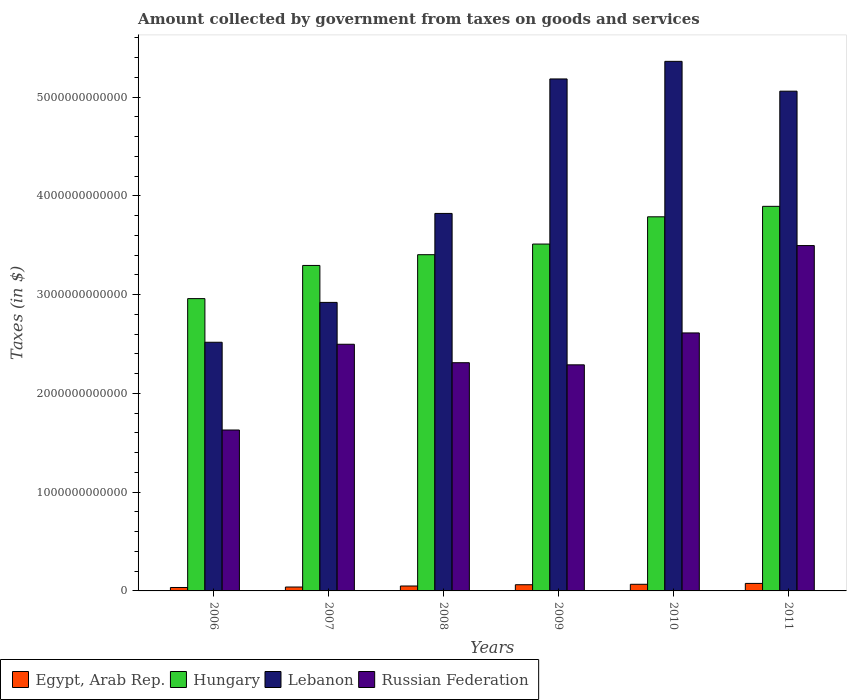How many bars are there on the 5th tick from the left?
Your response must be concise. 4. What is the label of the 5th group of bars from the left?
Make the answer very short. 2010. What is the amount collected by government from taxes on goods and services in Egypt, Arab Rep. in 2007?
Give a very brief answer. 3.94e+1. Across all years, what is the maximum amount collected by government from taxes on goods and services in Russian Federation?
Your response must be concise. 3.50e+12. Across all years, what is the minimum amount collected by government from taxes on goods and services in Egypt, Arab Rep.?
Your answer should be very brief. 3.47e+1. What is the total amount collected by government from taxes on goods and services in Hungary in the graph?
Your answer should be very brief. 2.09e+13. What is the difference between the amount collected by government from taxes on goods and services in Lebanon in 2008 and that in 2009?
Your response must be concise. -1.36e+12. What is the difference between the amount collected by government from taxes on goods and services in Egypt, Arab Rep. in 2007 and the amount collected by government from taxes on goods and services in Russian Federation in 2006?
Provide a short and direct response. -1.59e+12. What is the average amount collected by government from taxes on goods and services in Lebanon per year?
Offer a very short reply. 4.14e+12. In the year 2009, what is the difference between the amount collected by government from taxes on goods and services in Lebanon and amount collected by government from taxes on goods and services in Russian Federation?
Provide a short and direct response. 2.89e+12. What is the ratio of the amount collected by government from taxes on goods and services in Hungary in 2007 to that in 2009?
Your answer should be very brief. 0.94. What is the difference between the highest and the second highest amount collected by government from taxes on goods and services in Russian Federation?
Offer a terse response. 8.84e+11. What is the difference between the highest and the lowest amount collected by government from taxes on goods and services in Egypt, Arab Rep.?
Your answer should be very brief. 4.14e+1. In how many years, is the amount collected by government from taxes on goods and services in Egypt, Arab Rep. greater than the average amount collected by government from taxes on goods and services in Egypt, Arab Rep. taken over all years?
Your response must be concise. 3. What does the 2nd bar from the left in 2007 represents?
Offer a very short reply. Hungary. What does the 2nd bar from the right in 2006 represents?
Provide a succinct answer. Lebanon. Is it the case that in every year, the sum of the amount collected by government from taxes on goods and services in Hungary and amount collected by government from taxes on goods and services in Lebanon is greater than the amount collected by government from taxes on goods and services in Egypt, Arab Rep.?
Offer a very short reply. Yes. How many bars are there?
Offer a terse response. 24. Are all the bars in the graph horizontal?
Ensure brevity in your answer.  No. What is the difference between two consecutive major ticks on the Y-axis?
Your answer should be very brief. 1.00e+12. Does the graph contain grids?
Give a very brief answer. No. Where does the legend appear in the graph?
Make the answer very short. Bottom left. How are the legend labels stacked?
Your answer should be compact. Horizontal. What is the title of the graph?
Give a very brief answer. Amount collected by government from taxes on goods and services. What is the label or title of the X-axis?
Your response must be concise. Years. What is the label or title of the Y-axis?
Make the answer very short. Taxes (in $). What is the Taxes (in $) in Egypt, Arab Rep. in 2006?
Provide a short and direct response. 3.47e+1. What is the Taxes (in $) of Hungary in 2006?
Your response must be concise. 2.96e+12. What is the Taxes (in $) of Lebanon in 2006?
Your response must be concise. 2.52e+12. What is the Taxes (in $) of Russian Federation in 2006?
Keep it short and to the point. 1.63e+12. What is the Taxes (in $) in Egypt, Arab Rep. in 2007?
Your response must be concise. 3.94e+1. What is the Taxes (in $) in Hungary in 2007?
Make the answer very short. 3.30e+12. What is the Taxes (in $) in Lebanon in 2007?
Your response must be concise. 2.92e+12. What is the Taxes (in $) of Russian Federation in 2007?
Offer a very short reply. 2.50e+12. What is the Taxes (in $) in Egypt, Arab Rep. in 2008?
Ensure brevity in your answer.  4.97e+1. What is the Taxes (in $) in Hungary in 2008?
Keep it short and to the point. 3.40e+12. What is the Taxes (in $) in Lebanon in 2008?
Your answer should be very brief. 3.82e+12. What is the Taxes (in $) in Russian Federation in 2008?
Your answer should be very brief. 2.31e+12. What is the Taxes (in $) of Egypt, Arab Rep. in 2009?
Offer a terse response. 6.26e+1. What is the Taxes (in $) of Hungary in 2009?
Your response must be concise. 3.51e+12. What is the Taxes (in $) in Lebanon in 2009?
Offer a very short reply. 5.18e+12. What is the Taxes (in $) of Russian Federation in 2009?
Your answer should be compact. 2.29e+12. What is the Taxes (in $) of Egypt, Arab Rep. in 2010?
Your answer should be compact. 6.71e+1. What is the Taxes (in $) of Hungary in 2010?
Your answer should be very brief. 3.79e+12. What is the Taxes (in $) of Lebanon in 2010?
Give a very brief answer. 5.36e+12. What is the Taxes (in $) of Russian Federation in 2010?
Make the answer very short. 2.61e+12. What is the Taxes (in $) in Egypt, Arab Rep. in 2011?
Give a very brief answer. 7.61e+1. What is the Taxes (in $) in Hungary in 2011?
Keep it short and to the point. 3.89e+12. What is the Taxes (in $) in Lebanon in 2011?
Your answer should be very brief. 5.06e+12. What is the Taxes (in $) in Russian Federation in 2011?
Ensure brevity in your answer.  3.50e+12. Across all years, what is the maximum Taxes (in $) in Egypt, Arab Rep.?
Your response must be concise. 7.61e+1. Across all years, what is the maximum Taxes (in $) of Hungary?
Provide a short and direct response. 3.89e+12. Across all years, what is the maximum Taxes (in $) in Lebanon?
Your answer should be compact. 5.36e+12. Across all years, what is the maximum Taxes (in $) of Russian Federation?
Provide a short and direct response. 3.50e+12. Across all years, what is the minimum Taxes (in $) of Egypt, Arab Rep.?
Provide a short and direct response. 3.47e+1. Across all years, what is the minimum Taxes (in $) in Hungary?
Provide a short and direct response. 2.96e+12. Across all years, what is the minimum Taxes (in $) of Lebanon?
Offer a very short reply. 2.52e+12. Across all years, what is the minimum Taxes (in $) in Russian Federation?
Your answer should be very brief. 1.63e+12. What is the total Taxes (in $) of Egypt, Arab Rep. in the graph?
Provide a succinct answer. 3.30e+11. What is the total Taxes (in $) of Hungary in the graph?
Your answer should be compact. 2.09e+13. What is the total Taxes (in $) of Lebanon in the graph?
Your answer should be very brief. 2.49e+13. What is the total Taxes (in $) in Russian Federation in the graph?
Offer a very short reply. 1.48e+13. What is the difference between the Taxes (in $) of Egypt, Arab Rep. in 2006 and that in 2007?
Offer a very short reply. -4.74e+09. What is the difference between the Taxes (in $) of Hungary in 2006 and that in 2007?
Give a very brief answer. -3.36e+11. What is the difference between the Taxes (in $) in Lebanon in 2006 and that in 2007?
Your answer should be compact. -4.04e+11. What is the difference between the Taxes (in $) in Russian Federation in 2006 and that in 2007?
Provide a succinct answer. -8.68e+11. What is the difference between the Taxes (in $) of Egypt, Arab Rep. in 2006 and that in 2008?
Make the answer very short. -1.50e+1. What is the difference between the Taxes (in $) in Hungary in 2006 and that in 2008?
Provide a succinct answer. -4.45e+11. What is the difference between the Taxes (in $) of Lebanon in 2006 and that in 2008?
Ensure brevity in your answer.  -1.30e+12. What is the difference between the Taxes (in $) of Russian Federation in 2006 and that in 2008?
Offer a very short reply. -6.81e+11. What is the difference between the Taxes (in $) of Egypt, Arab Rep. in 2006 and that in 2009?
Keep it short and to the point. -2.80e+1. What is the difference between the Taxes (in $) of Hungary in 2006 and that in 2009?
Keep it short and to the point. -5.52e+11. What is the difference between the Taxes (in $) in Lebanon in 2006 and that in 2009?
Provide a succinct answer. -2.67e+12. What is the difference between the Taxes (in $) of Russian Federation in 2006 and that in 2009?
Provide a short and direct response. -6.60e+11. What is the difference between the Taxes (in $) in Egypt, Arab Rep. in 2006 and that in 2010?
Provide a succinct answer. -3.24e+1. What is the difference between the Taxes (in $) of Hungary in 2006 and that in 2010?
Offer a very short reply. -8.28e+11. What is the difference between the Taxes (in $) of Lebanon in 2006 and that in 2010?
Provide a short and direct response. -2.84e+12. What is the difference between the Taxes (in $) in Russian Federation in 2006 and that in 2010?
Offer a terse response. -9.83e+11. What is the difference between the Taxes (in $) in Egypt, Arab Rep. in 2006 and that in 2011?
Keep it short and to the point. -4.14e+1. What is the difference between the Taxes (in $) of Hungary in 2006 and that in 2011?
Your answer should be compact. -9.34e+11. What is the difference between the Taxes (in $) in Lebanon in 2006 and that in 2011?
Provide a short and direct response. -2.54e+12. What is the difference between the Taxes (in $) of Russian Federation in 2006 and that in 2011?
Provide a short and direct response. -1.87e+12. What is the difference between the Taxes (in $) of Egypt, Arab Rep. in 2007 and that in 2008?
Your answer should be very brief. -1.03e+1. What is the difference between the Taxes (in $) of Hungary in 2007 and that in 2008?
Give a very brief answer. -1.09e+11. What is the difference between the Taxes (in $) of Lebanon in 2007 and that in 2008?
Ensure brevity in your answer.  -9.01e+11. What is the difference between the Taxes (in $) of Russian Federation in 2007 and that in 2008?
Make the answer very short. 1.87e+11. What is the difference between the Taxes (in $) of Egypt, Arab Rep. in 2007 and that in 2009?
Your response must be concise. -2.32e+1. What is the difference between the Taxes (in $) of Hungary in 2007 and that in 2009?
Make the answer very short. -2.17e+11. What is the difference between the Taxes (in $) of Lebanon in 2007 and that in 2009?
Your response must be concise. -2.26e+12. What is the difference between the Taxes (in $) of Russian Federation in 2007 and that in 2009?
Your response must be concise. 2.08e+11. What is the difference between the Taxes (in $) of Egypt, Arab Rep. in 2007 and that in 2010?
Offer a terse response. -2.77e+1. What is the difference between the Taxes (in $) of Hungary in 2007 and that in 2010?
Provide a short and direct response. -4.93e+11. What is the difference between the Taxes (in $) in Lebanon in 2007 and that in 2010?
Provide a succinct answer. -2.44e+12. What is the difference between the Taxes (in $) in Russian Federation in 2007 and that in 2010?
Give a very brief answer. -1.15e+11. What is the difference between the Taxes (in $) of Egypt, Arab Rep. in 2007 and that in 2011?
Keep it short and to the point. -3.66e+1. What is the difference between the Taxes (in $) of Hungary in 2007 and that in 2011?
Provide a short and direct response. -5.98e+11. What is the difference between the Taxes (in $) of Lebanon in 2007 and that in 2011?
Give a very brief answer. -2.14e+12. What is the difference between the Taxes (in $) in Russian Federation in 2007 and that in 2011?
Offer a very short reply. -9.99e+11. What is the difference between the Taxes (in $) of Egypt, Arab Rep. in 2008 and that in 2009?
Provide a short and direct response. -1.29e+1. What is the difference between the Taxes (in $) of Hungary in 2008 and that in 2009?
Your response must be concise. -1.08e+11. What is the difference between the Taxes (in $) of Lebanon in 2008 and that in 2009?
Offer a very short reply. -1.36e+12. What is the difference between the Taxes (in $) in Russian Federation in 2008 and that in 2009?
Your answer should be compact. 2.16e+1. What is the difference between the Taxes (in $) in Egypt, Arab Rep. in 2008 and that in 2010?
Offer a very short reply. -1.73e+1. What is the difference between the Taxes (in $) of Hungary in 2008 and that in 2010?
Ensure brevity in your answer.  -3.84e+11. What is the difference between the Taxes (in $) in Lebanon in 2008 and that in 2010?
Offer a terse response. -1.54e+12. What is the difference between the Taxes (in $) of Russian Federation in 2008 and that in 2010?
Provide a short and direct response. -3.01e+11. What is the difference between the Taxes (in $) in Egypt, Arab Rep. in 2008 and that in 2011?
Your response must be concise. -2.63e+1. What is the difference between the Taxes (in $) of Hungary in 2008 and that in 2011?
Ensure brevity in your answer.  -4.90e+11. What is the difference between the Taxes (in $) in Lebanon in 2008 and that in 2011?
Offer a terse response. -1.24e+12. What is the difference between the Taxes (in $) in Russian Federation in 2008 and that in 2011?
Offer a terse response. -1.19e+12. What is the difference between the Taxes (in $) in Egypt, Arab Rep. in 2009 and that in 2010?
Ensure brevity in your answer.  -4.44e+09. What is the difference between the Taxes (in $) in Hungary in 2009 and that in 2010?
Your answer should be compact. -2.76e+11. What is the difference between the Taxes (in $) of Lebanon in 2009 and that in 2010?
Your answer should be compact. -1.78e+11. What is the difference between the Taxes (in $) in Russian Federation in 2009 and that in 2010?
Your response must be concise. -3.23e+11. What is the difference between the Taxes (in $) in Egypt, Arab Rep. in 2009 and that in 2011?
Keep it short and to the point. -1.34e+1. What is the difference between the Taxes (in $) in Hungary in 2009 and that in 2011?
Give a very brief answer. -3.82e+11. What is the difference between the Taxes (in $) of Lebanon in 2009 and that in 2011?
Provide a succinct answer. 1.24e+11. What is the difference between the Taxes (in $) in Russian Federation in 2009 and that in 2011?
Your answer should be compact. -1.21e+12. What is the difference between the Taxes (in $) in Egypt, Arab Rep. in 2010 and that in 2011?
Provide a short and direct response. -8.97e+09. What is the difference between the Taxes (in $) of Hungary in 2010 and that in 2011?
Make the answer very short. -1.06e+11. What is the difference between the Taxes (in $) of Lebanon in 2010 and that in 2011?
Your answer should be compact. 3.02e+11. What is the difference between the Taxes (in $) of Russian Federation in 2010 and that in 2011?
Give a very brief answer. -8.84e+11. What is the difference between the Taxes (in $) of Egypt, Arab Rep. in 2006 and the Taxes (in $) of Hungary in 2007?
Offer a terse response. -3.26e+12. What is the difference between the Taxes (in $) of Egypt, Arab Rep. in 2006 and the Taxes (in $) of Lebanon in 2007?
Give a very brief answer. -2.89e+12. What is the difference between the Taxes (in $) in Egypt, Arab Rep. in 2006 and the Taxes (in $) in Russian Federation in 2007?
Provide a succinct answer. -2.46e+12. What is the difference between the Taxes (in $) of Hungary in 2006 and the Taxes (in $) of Lebanon in 2007?
Offer a very short reply. 3.82e+1. What is the difference between the Taxes (in $) in Hungary in 2006 and the Taxes (in $) in Russian Federation in 2007?
Keep it short and to the point. 4.62e+11. What is the difference between the Taxes (in $) in Lebanon in 2006 and the Taxes (in $) in Russian Federation in 2007?
Provide a short and direct response. 2.02e+1. What is the difference between the Taxes (in $) in Egypt, Arab Rep. in 2006 and the Taxes (in $) in Hungary in 2008?
Offer a terse response. -3.37e+12. What is the difference between the Taxes (in $) of Egypt, Arab Rep. in 2006 and the Taxes (in $) of Lebanon in 2008?
Offer a very short reply. -3.79e+12. What is the difference between the Taxes (in $) in Egypt, Arab Rep. in 2006 and the Taxes (in $) in Russian Federation in 2008?
Your answer should be very brief. -2.28e+12. What is the difference between the Taxes (in $) in Hungary in 2006 and the Taxes (in $) in Lebanon in 2008?
Provide a succinct answer. -8.63e+11. What is the difference between the Taxes (in $) in Hungary in 2006 and the Taxes (in $) in Russian Federation in 2008?
Provide a short and direct response. 6.49e+11. What is the difference between the Taxes (in $) in Lebanon in 2006 and the Taxes (in $) in Russian Federation in 2008?
Make the answer very short. 2.07e+11. What is the difference between the Taxes (in $) of Egypt, Arab Rep. in 2006 and the Taxes (in $) of Hungary in 2009?
Make the answer very short. -3.48e+12. What is the difference between the Taxes (in $) of Egypt, Arab Rep. in 2006 and the Taxes (in $) of Lebanon in 2009?
Offer a terse response. -5.15e+12. What is the difference between the Taxes (in $) of Egypt, Arab Rep. in 2006 and the Taxes (in $) of Russian Federation in 2009?
Make the answer very short. -2.25e+12. What is the difference between the Taxes (in $) in Hungary in 2006 and the Taxes (in $) in Lebanon in 2009?
Your answer should be compact. -2.22e+12. What is the difference between the Taxes (in $) in Hungary in 2006 and the Taxes (in $) in Russian Federation in 2009?
Keep it short and to the point. 6.70e+11. What is the difference between the Taxes (in $) of Lebanon in 2006 and the Taxes (in $) of Russian Federation in 2009?
Make the answer very short. 2.29e+11. What is the difference between the Taxes (in $) of Egypt, Arab Rep. in 2006 and the Taxes (in $) of Hungary in 2010?
Your answer should be very brief. -3.75e+12. What is the difference between the Taxes (in $) in Egypt, Arab Rep. in 2006 and the Taxes (in $) in Lebanon in 2010?
Offer a terse response. -5.33e+12. What is the difference between the Taxes (in $) of Egypt, Arab Rep. in 2006 and the Taxes (in $) of Russian Federation in 2010?
Offer a very short reply. -2.58e+12. What is the difference between the Taxes (in $) of Hungary in 2006 and the Taxes (in $) of Lebanon in 2010?
Give a very brief answer. -2.40e+12. What is the difference between the Taxes (in $) in Hungary in 2006 and the Taxes (in $) in Russian Federation in 2010?
Provide a succinct answer. 3.47e+11. What is the difference between the Taxes (in $) in Lebanon in 2006 and the Taxes (in $) in Russian Federation in 2010?
Make the answer very short. -9.44e+1. What is the difference between the Taxes (in $) of Egypt, Arab Rep. in 2006 and the Taxes (in $) of Hungary in 2011?
Keep it short and to the point. -3.86e+12. What is the difference between the Taxes (in $) in Egypt, Arab Rep. in 2006 and the Taxes (in $) in Lebanon in 2011?
Offer a very short reply. -5.02e+12. What is the difference between the Taxes (in $) of Egypt, Arab Rep. in 2006 and the Taxes (in $) of Russian Federation in 2011?
Your response must be concise. -3.46e+12. What is the difference between the Taxes (in $) in Hungary in 2006 and the Taxes (in $) in Lebanon in 2011?
Your answer should be compact. -2.10e+12. What is the difference between the Taxes (in $) of Hungary in 2006 and the Taxes (in $) of Russian Federation in 2011?
Provide a short and direct response. -5.37e+11. What is the difference between the Taxes (in $) in Lebanon in 2006 and the Taxes (in $) in Russian Federation in 2011?
Ensure brevity in your answer.  -9.79e+11. What is the difference between the Taxes (in $) in Egypt, Arab Rep. in 2007 and the Taxes (in $) in Hungary in 2008?
Provide a succinct answer. -3.36e+12. What is the difference between the Taxes (in $) of Egypt, Arab Rep. in 2007 and the Taxes (in $) of Lebanon in 2008?
Your answer should be compact. -3.78e+12. What is the difference between the Taxes (in $) of Egypt, Arab Rep. in 2007 and the Taxes (in $) of Russian Federation in 2008?
Give a very brief answer. -2.27e+12. What is the difference between the Taxes (in $) in Hungary in 2007 and the Taxes (in $) in Lebanon in 2008?
Your answer should be compact. -5.27e+11. What is the difference between the Taxes (in $) in Hungary in 2007 and the Taxes (in $) in Russian Federation in 2008?
Your answer should be compact. 9.85e+11. What is the difference between the Taxes (in $) of Lebanon in 2007 and the Taxes (in $) of Russian Federation in 2008?
Your answer should be very brief. 6.11e+11. What is the difference between the Taxes (in $) of Egypt, Arab Rep. in 2007 and the Taxes (in $) of Hungary in 2009?
Give a very brief answer. -3.47e+12. What is the difference between the Taxes (in $) of Egypt, Arab Rep. in 2007 and the Taxes (in $) of Lebanon in 2009?
Provide a succinct answer. -5.14e+12. What is the difference between the Taxes (in $) of Egypt, Arab Rep. in 2007 and the Taxes (in $) of Russian Federation in 2009?
Give a very brief answer. -2.25e+12. What is the difference between the Taxes (in $) of Hungary in 2007 and the Taxes (in $) of Lebanon in 2009?
Provide a succinct answer. -1.89e+12. What is the difference between the Taxes (in $) of Hungary in 2007 and the Taxes (in $) of Russian Federation in 2009?
Your answer should be compact. 1.01e+12. What is the difference between the Taxes (in $) in Lebanon in 2007 and the Taxes (in $) in Russian Federation in 2009?
Your response must be concise. 6.32e+11. What is the difference between the Taxes (in $) in Egypt, Arab Rep. in 2007 and the Taxes (in $) in Hungary in 2010?
Keep it short and to the point. -3.75e+12. What is the difference between the Taxes (in $) of Egypt, Arab Rep. in 2007 and the Taxes (in $) of Lebanon in 2010?
Offer a very short reply. -5.32e+12. What is the difference between the Taxes (in $) in Egypt, Arab Rep. in 2007 and the Taxes (in $) in Russian Federation in 2010?
Make the answer very short. -2.57e+12. What is the difference between the Taxes (in $) in Hungary in 2007 and the Taxes (in $) in Lebanon in 2010?
Provide a succinct answer. -2.07e+12. What is the difference between the Taxes (in $) of Hungary in 2007 and the Taxes (in $) of Russian Federation in 2010?
Offer a terse response. 6.83e+11. What is the difference between the Taxes (in $) of Lebanon in 2007 and the Taxes (in $) of Russian Federation in 2010?
Give a very brief answer. 3.09e+11. What is the difference between the Taxes (in $) in Egypt, Arab Rep. in 2007 and the Taxes (in $) in Hungary in 2011?
Provide a short and direct response. -3.85e+12. What is the difference between the Taxes (in $) in Egypt, Arab Rep. in 2007 and the Taxes (in $) in Lebanon in 2011?
Your answer should be very brief. -5.02e+12. What is the difference between the Taxes (in $) of Egypt, Arab Rep. in 2007 and the Taxes (in $) of Russian Federation in 2011?
Provide a short and direct response. -3.46e+12. What is the difference between the Taxes (in $) in Hungary in 2007 and the Taxes (in $) in Lebanon in 2011?
Your answer should be compact. -1.76e+12. What is the difference between the Taxes (in $) in Hungary in 2007 and the Taxes (in $) in Russian Federation in 2011?
Your response must be concise. -2.01e+11. What is the difference between the Taxes (in $) in Lebanon in 2007 and the Taxes (in $) in Russian Federation in 2011?
Your answer should be very brief. -5.75e+11. What is the difference between the Taxes (in $) in Egypt, Arab Rep. in 2008 and the Taxes (in $) in Hungary in 2009?
Ensure brevity in your answer.  -3.46e+12. What is the difference between the Taxes (in $) of Egypt, Arab Rep. in 2008 and the Taxes (in $) of Lebanon in 2009?
Your answer should be compact. -5.13e+12. What is the difference between the Taxes (in $) of Egypt, Arab Rep. in 2008 and the Taxes (in $) of Russian Federation in 2009?
Your response must be concise. -2.24e+12. What is the difference between the Taxes (in $) in Hungary in 2008 and the Taxes (in $) in Lebanon in 2009?
Your answer should be very brief. -1.78e+12. What is the difference between the Taxes (in $) in Hungary in 2008 and the Taxes (in $) in Russian Federation in 2009?
Your answer should be very brief. 1.12e+12. What is the difference between the Taxes (in $) in Lebanon in 2008 and the Taxes (in $) in Russian Federation in 2009?
Provide a succinct answer. 1.53e+12. What is the difference between the Taxes (in $) in Egypt, Arab Rep. in 2008 and the Taxes (in $) in Hungary in 2010?
Provide a short and direct response. -3.74e+12. What is the difference between the Taxes (in $) of Egypt, Arab Rep. in 2008 and the Taxes (in $) of Lebanon in 2010?
Give a very brief answer. -5.31e+12. What is the difference between the Taxes (in $) in Egypt, Arab Rep. in 2008 and the Taxes (in $) in Russian Federation in 2010?
Provide a short and direct response. -2.56e+12. What is the difference between the Taxes (in $) in Hungary in 2008 and the Taxes (in $) in Lebanon in 2010?
Your answer should be compact. -1.96e+12. What is the difference between the Taxes (in $) in Hungary in 2008 and the Taxes (in $) in Russian Federation in 2010?
Provide a succinct answer. 7.92e+11. What is the difference between the Taxes (in $) of Lebanon in 2008 and the Taxes (in $) of Russian Federation in 2010?
Offer a terse response. 1.21e+12. What is the difference between the Taxes (in $) of Egypt, Arab Rep. in 2008 and the Taxes (in $) of Hungary in 2011?
Provide a short and direct response. -3.84e+12. What is the difference between the Taxes (in $) of Egypt, Arab Rep. in 2008 and the Taxes (in $) of Lebanon in 2011?
Provide a succinct answer. -5.01e+12. What is the difference between the Taxes (in $) of Egypt, Arab Rep. in 2008 and the Taxes (in $) of Russian Federation in 2011?
Ensure brevity in your answer.  -3.45e+12. What is the difference between the Taxes (in $) of Hungary in 2008 and the Taxes (in $) of Lebanon in 2011?
Keep it short and to the point. -1.66e+12. What is the difference between the Taxes (in $) in Hungary in 2008 and the Taxes (in $) in Russian Federation in 2011?
Offer a very short reply. -9.24e+1. What is the difference between the Taxes (in $) of Lebanon in 2008 and the Taxes (in $) of Russian Federation in 2011?
Keep it short and to the point. 3.25e+11. What is the difference between the Taxes (in $) of Egypt, Arab Rep. in 2009 and the Taxes (in $) of Hungary in 2010?
Make the answer very short. -3.73e+12. What is the difference between the Taxes (in $) in Egypt, Arab Rep. in 2009 and the Taxes (in $) in Lebanon in 2010?
Make the answer very short. -5.30e+12. What is the difference between the Taxes (in $) of Egypt, Arab Rep. in 2009 and the Taxes (in $) of Russian Federation in 2010?
Give a very brief answer. -2.55e+12. What is the difference between the Taxes (in $) of Hungary in 2009 and the Taxes (in $) of Lebanon in 2010?
Ensure brevity in your answer.  -1.85e+12. What is the difference between the Taxes (in $) of Hungary in 2009 and the Taxes (in $) of Russian Federation in 2010?
Your response must be concise. 9.00e+11. What is the difference between the Taxes (in $) of Lebanon in 2009 and the Taxes (in $) of Russian Federation in 2010?
Keep it short and to the point. 2.57e+12. What is the difference between the Taxes (in $) of Egypt, Arab Rep. in 2009 and the Taxes (in $) of Hungary in 2011?
Provide a succinct answer. -3.83e+12. What is the difference between the Taxes (in $) in Egypt, Arab Rep. in 2009 and the Taxes (in $) in Lebanon in 2011?
Ensure brevity in your answer.  -5.00e+12. What is the difference between the Taxes (in $) in Egypt, Arab Rep. in 2009 and the Taxes (in $) in Russian Federation in 2011?
Offer a terse response. -3.43e+12. What is the difference between the Taxes (in $) in Hungary in 2009 and the Taxes (in $) in Lebanon in 2011?
Your answer should be very brief. -1.55e+12. What is the difference between the Taxes (in $) of Hungary in 2009 and the Taxes (in $) of Russian Federation in 2011?
Offer a very short reply. 1.54e+1. What is the difference between the Taxes (in $) of Lebanon in 2009 and the Taxes (in $) of Russian Federation in 2011?
Provide a succinct answer. 1.69e+12. What is the difference between the Taxes (in $) in Egypt, Arab Rep. in 2010 and the Taxes (in $) in Hungary in 2011?
Make the answer very short. -3.83e+12. What is the difference between the Taxes (in $) in Egypt, Arab Rep. in 2010 and the Taxes (in $) in Lebanon in 2011?
Give a very brief answer. -4.99e+12. What is the difference between the Taxes (in $) of Egypt, Arab Rep. in 2010 and the Taxes (in $) of Russian Federation in 2011?
Provide a short and direct response. -3.43e+12. What is the difference between the Taxes (in $) of Hungary in 2010 and the Taxes (in $) of Lebanon in 2011?
Make the answer very short. -1.27e+12. What is the difference between the Taxes (in $) of Hungary in 2010 and the Taxes (in $) of Russian Federation in 2011?
Give a very brief answer. 2.91e+11. What is the difference between the Taxes (in $) of Lebanon in 2010 and the Taxes (in $) of Russian Federation in 2011?
Offer a terse response. 1.87e+12. What is the average Taxes (in $) in Egypt, Arab Rep. per year?
Your response must be concise. 5.49e+1. What is the average Taxes (in $) of Hungary per year?
Keep it short and to the point. 3.48e+12. What is the average Taxes (in $) of Lebanon per year?
Keep it short and to the point. 4.14e+12. What is the average Taxes (in $) in Russian Federation per year?
Ensure brevity in your answer.  2.47e+12. In the year 2006, what is the difference between the Taxes (in $) in Egypt, Arab Rep. and Taxes (in $) in Hungary?
Offer a very short reply. -2.92e+12. In the year 2006, what is the difference between the Taxes (in $) of Egypt, Arab Rep. and Taxes (in $) of Lebanon?
Your response must be concise. -2.48e+12. In the year 2006, what is the difference between the Taxes (in $) of Egypt, Arab Rep. and Taxes (in $) of Russian Federation?
Your response must be concise. -1.59e+12. In the year 2006, what is the difference between the Taxes (in $) of Hungary and Taxes (in $) of Lebanon?
Ensure brevity in your answer.  4.42e+11. In the year 2006, what is the difference between the Taxes (in $) in Hungary and Taxes (in $) in Russian Federation?
Offer a very short reply. 1.33e+12. In the year 2006, what is the difference between the Taxes (in $) of Lebanon and Taxes (in $) of Russian Federation?
Give a very brief answer. 8.88e+11. In the year 2007, what is the difference between the Taxes (in $) in Egypt, Arab Rep. and Taxes (in $) in Hungary?
Your response must be concise. -3.26e+12. In the year 2007, what is the difference between the Taxes (in $) in Egypt, Arab Rep. and Taxes (in $) in Lebanon?
Provide a succinct answer. -2.88e+12. In the year 2007, what is the difference between the Taxes (in $) of Egypt, Arab Rep. and Taxes (in $) of Russian Federation?
Your response must be concise. -2.46e+12. In the year 2007, what is the difference between the Taxes (in $) in Hungary and Taxes (in $) in Lebanon?
Offer a very short reply. 3.74e+11. In the year 2007, what is the difference between the Taxes (in $) in Hungary and Taxes (in $) in Russian Federation?
Your response must be concise. 7.98e+11. In the year 2007, what is the difference between the Taxes (in $) of Lebanon and Taxes (in $) of Russian Federation?
Make the answer very short. 4.24e+11. In the year 2008, what is the difference between the Taxes (in $) of Egypt, Arab Rep. and Taxes (in $) of Hungary?
Give a very brief answer. -3.35e+12. In the year 2008, what is the difference between the Taxes (in $) in Egypt, Arab Rep. and Taxes (in $) in Lebanon?
Keep it short and to the point. -3.77e+12. In the year 2008, what is the difference between the Taxes (in $) in Egypt, Arab Rep. and Taxes (in $) in Russian Federation?
Your answer should be very brief. -2.26e+12. In the year 2008, what is the difference between the Taxes (in $) in Hungary and Taxes (in $) in Lebanon?
Your answer should be compact. -4.18e+11. In the year 2008, what is the difference between the Taxes (in $) of Hungary and Taxes (in $) of Russian Federation?
Your response must be concise. 1.09e+12. In the year 2008, what is the difference between the Taxes (in $) in Lebanon and Taxes (in $) in Russian Federation?
Provide a succinct answer. 1.51e+12. In the year 2009, what is the difference between the Taxes (in $) in Egypt, Arab Rep. and Taxes (in $) in Hungary?
Offer a very short reply. -3.45e+12. In the year 2009, what is the difference between the Taxes (in $) in Egypt, Arab Rep. and Taxes (in $) in Lebanon?
Your answer should be compact. -5.12e+12. In the year 2009, what is the difference between the Taxes (in $) of Egypt, Arab Rep. and Taxes (in $) of Russian Federation?
Your answer should be very brief. -2.23e+12. In the year 2009, what is the difference between the Taxes (in $) of Hungary and Taxes (in $) of Lebanon?
Ensure brevity in your answer.  -1.67e+12. In the year 2009, what is the difference between the Taxes (in $) of Hungary and Taxes (in $) of Russian Federation?
Your answer should be very brief. 1.22e+12. In the year 2009, what is the difference between the Taxes (in $) of Lebanon and Taxes (in $) of Russian Federation?
Ensure brevity in your answer.  2.89e+12. In the year 2010, what is the difference between the Taxes (in $) in Egypt, Arab Rep. and Taxes (in $) in Hungary?
Keep it short and to the point. -3.72e+12. In the year 2010, what is the difference between the Taxes (in $) of Egypt, Arab Rep. and Taxes (in $) of Lebanon?
Your answer should be very brief. -5.29e+12. In the year 2010, what is the difference between the Taxes (in $) of Egypt, Arab Rep. and Taxes (in $) of Russian Federation?
Make the answer very short. -2.54e+12. In the year 2010, what is the difference between the Taxes (in $) in Hungary and Taxes (in $) in Lebanon?
Your answer should be compact. -1.57e+12. In the year 2010, what is the difference between the Taxes (in $) of Hungary and Taxes (in $) of Russian Federation?
Your answer should be compact. 1.18e+12. In the year 2010, what is the difference between the Taxes (in $) of Lebanon and Taxes (in $) of Russian Federation?
Provide a succinct answer. 2.75e+12. In the year 2011, what is the difference between the Taxes (in $) in Egypt, Arab Rep. and Taxes (in $) in Hungary?
Make the answer very short. -3.82e+12. In the year 2011, what is the difference between the Taxes (in $) in Egypt, Arab Rep. and Taxes (in $) in Lebanon?
Your answer should be compact. -4.98e+12. In the year 2011, what is the difference between the Taxes (in $) of Egypt, Arab Rep. and Taxes (in $) of Russian Federation?
Your response must be concise. -3.42e+12. In the year 2011, what is the difference between the Taxes (in $) of Hungary and Taxes (in $) of Lebanon?
Keep it short and to the point. -1.17e+12. In the year 2011, what is the difference between the Taxes (in $) in Hungary and Taxes (in $) in Russian Federation?
Provide a succinct answer. 3.97e+11. In the year 2011, what is the difference between the Taxes (in $) in Lebanon and Taxes (in $) in Russian Federation?
Make the answer very short. 1.56e+12. What is the ratio of the Taxes (in $) in Egypt, Arab Rep. in 2006 to that in 2007?
Give a very brief answer. 0.88. What is the ratio of the Taxes (in $) in Hungary in 2006 to that in 2007?
Your answer should be compact. 0.9. What is the ratio of the Taxes (in $) of Lebanon in 2006 to that in 2007?
Provide a short and direct response. 0.86. What is the ratio of the Taxes (in $) of Russian Federation in 2006 to that in 2007?
Your response must be concise. 0.65. What is the ratio of the Taxes (in $) in Egypt, Arab Rep. in 2006 to that in 2008?
Provide a short and direct response. 0.7. What is the ratio of the Taxes (in $) of Hungary in 2006 to that in 2008?
Your answer should be very brief. 0.87. What is the ratio of the Taxes (in $) of Lebanon in 2006 to that in 2008?
Offer a terse response. 0.66. What is the ratio of the Taxes (in $) of Russian Federation in 2006 to that in 2008?
Make the answer very short. 0.71. What is the ratio of the Taxes (in $) of Egypt, Arab Rep. in 2006 to that in 2009?
Provide a short and direct response. 0.55. What is the ratio of the Taxes (in $) in Hungary in 2006 to that in 2009?
Your answer should be compact. 0.84. What is the ratio of the Taxes (in $) in Lebanon in 2006 to that in 2009?
Keep it short and to the point. 0.49. What is the ratio of the Taxes (in $) of Russian Federation in 2006 to that in 2009?
Provide a short and direct response. 0.71. What is the ratio of the Taxes (in $) of Egypt, Arab Rep. in 2006 to that in 2010?
Make the answer very short. 0.52. What is the ratio of the Taxes (in $) in Hungary in 2006 to that in 2010?
Give a very brief answer. 0.78. What is the ratio of the Taxes (in $) of Lebanon in 2006 to that in 2010?
Offer a very short reply. 0.47. What is the ratio of the Taxes (in $) of Russian Federation in 2006 to that in 2010?
Keep it short and to the point. 0.62. What is the ratio of the Taxes (in $) in Egypt, Arab Rep. in 2006 to that in 2011?
Provide a short and direct response. 0.46. What is the ratio of the Taxes (in $) in Hungary in 2006 to that in 2011?
Provide a succinct answer. 0.76. What is the ratio of the Taxes (in $) in Lebanon in 2006 to that in 2011?
Provide a short and direct response. 0.5. What is the ratio of the Taxes (in $) in Russian Federation in 2006 to that in 2011?
Your response must be concise. 0.47. What is the ratio of the Taxes (in $) of Egypt, Arab Rep. in 2007 to that in 2008?
Offer a very short reply. 0.79. What is the ratio of the Taxes (in $) in Hungary in 2007 to that in 2008?
Your answer should be very brief. 0.97. What is the ratio of the Taxes (in $) of Lebanon in 2007 to that in 2008?
Your answer should be compact. 0.76. What is the ratio of the Taxes (in $) in Russian Federation in 2007 to that in 2008?
Provide a short and direct response. 1.08. What is the ratio of the Taxes (in $) in Egypt, Arab Rep. in 2007 to that in 2009?
Provide a succinct answer. 0.63. What is the ratio of the Taxes (in $) of Hungary in 2007 to that in 2009?
Your answer should be compact. 0.94. What is the ratio of the Taxes (in $) of Lebanon in 2007 to that in 2009?
Give a very brief answer. 0.56. What is the ratio of the Taxes (in $) of Russian Federation in 2007 to that in 2009?
Your response must be concise. 1.09. What is the ratio of the Taxes (in $) in Egypt, Arab Rep. in 2007 to that in 2010?
Your answer should be compact. 0.59. What is the ratio of the Taxes (in $) of Hungary in 2007 to that in 2010?
Give a very brief answer. 0.87. What is the ratio of the Taxes (in $) of Lebanon in 2007 to that in 2010?
Your answer should be compact. 0.54. What is the ratio of the Taxes (in $) in Russian Federation in 2007 to that in 2010?
Keep it short and to the point. 0.96. What is the ratio of the Taxes (in $) of Egypt, Arab Rep. in 2007 to that in 2011?
Provide a short and direct response. 0.52. What is the ratio of the Taxes (in $) in Hungary in 2007 to that in 2011?
Offer a very short reply. 0.85. What is the ratio of the Taxes (in $) of Lebanon in 2007 to that in 2011?
Provide a succinct answer. 0.58. What is the ratio of the Taxes (in $) of Russian Federation in 2007 to that in 2011?
Make the answer very short. 0.71. What is the ratio of the Taxes (in $) of Egypt, Arab Rep. in 2008 to that in 2009?
Keep it short and to the point. 0.79. What is the ratio of the Taxes (in $) of Hungary in 2008 to that in 2009?
Make the answer very short. 0.97. What is the ratio of the Taxes (in $) in Lebanon in 2008 to that in 2009?
Provide a succinct answer. 0.74. What is the ratio of the Taxes (in $) of Russian Federation in 2008 to that in 2009?
Your answer should be very brief. 1.01. What is the ratio of the Taxes (in $) of Egypt, Arab Rep. in 2008 to that in 2010?
Provide a succinct answer. 0.74. What is the ratio of the Taxes (in $) in Hungary in 2008 to that in 2010?
Keep it short and to the point. 0.9. What is the ratio of the Taxes (in $) in Lebanon in 2008 to that in 2010?
Give a very brief answer. 0.71. What is the ratio of the Taxes (in $) of Russian Federation in 2008 to that in 2010?
Offer a terse response. 0.88. What is the ratio of the Taxes (in $) in Egypt, Arab Rep. in 2008 to that in 2011?
Offer a terse response. 0.65. What is the ratio of the Taxes (in $) in Hungary in 2008 to that in 2011?
Your answer should be compact. 0.87. What is the ratio of the Taxes (in $) in Lebanon in 2008 to that in 2011?
Keep it short and to the point. 0.76. What is the ratio of the Taxes (in $) in Russian Federation in 2008 to that in 2011?
Your answer should be very brief. 0.66. What is the ratio of the Taxes (in $) of Egypt, Arab Rep. in 2009 to that in 2010?
Your answer should be very brief. 0.93. What is the ratio of the Taxes (in $) of Hungary in 2009 to that in 2010?
Give a very brief answer. 0.93. What is the ratio of the Taxes (in $) of Lebanon in 2009 to that in 2010?
Make the answer very short. 0.97. What is the ratio of the Taxes (in $) of Russian Federation in 2009 to that in 2010?
Your answer should be compact. 0.88. What is the ratio of the Taxes (in $) in Egypt, Arab Rep. in 2009 to that in 2011?
Give a very brief answer. 0.82. What is the ratio of the Taxes (in $) of Hungary in 2009 to that in 2011?
Your answer should be compact. 0.9. What is the ratio of the Taxes (in $) of Lebanon in 2009 to that in 2011?
Your response must be concise. 1.02. What is the ratio of the Taxes (in $) of Russian Federation in 2009 to that in 2011?
Make the answer very short. 0.65. What is the ratio of the Taxes (in $) of Egypt, Arab Rep. in 2010 to that in 2011?
Make the answer very short. 0.88. What is the ratio of the Taxes (in $) of Hungary in 2010 to that in 2011?
Provide a short and direct response. 0.97. What is the ratio of the Taxes (in $) in Lebanon in 2010 to that in 2011?
Your answer should be compact. 1.06. What is the ratio of the Taxes (in $) of Russian Federation in 2010 to that in 2011?
Offer a terse response. 0.75. What is the difference between the highest and the second highest Taxes (in $) in Egypt, Arab Rep.?
Provide a short and direct response. 8.97e+09. What is the difference between the highest and the second highest Taxes (in $) of Hungary?
Provide a short and direct response. 1.06e+11. What is the difference between the highest and the second highest Taxes (in $) in Lebanon?
Provide a short and direct response. 1.78e+11. What is the difference between the highest and the second highest Taxes (in $) of Russian Federation?
Offer a terse response. 8.84e+11. What is the difference between the highest and the lowest Taxes (in $) in Egypt, Arab Rep.?
Your answer should be compact. 4.14e+1. What is the difference between the highest and the lowest Taxes (in $) in Hungary?
Offer a very short reply. 9.34e+11. What is the difference between the highest and the lowest Taxes (in $) of Lebanon?
Offer a very short reply. 2.84e+12. What is the difference between the highest and the lowest Taxes (in $) in Russian Federation?
Make the answer very short. 1.87e+12. 